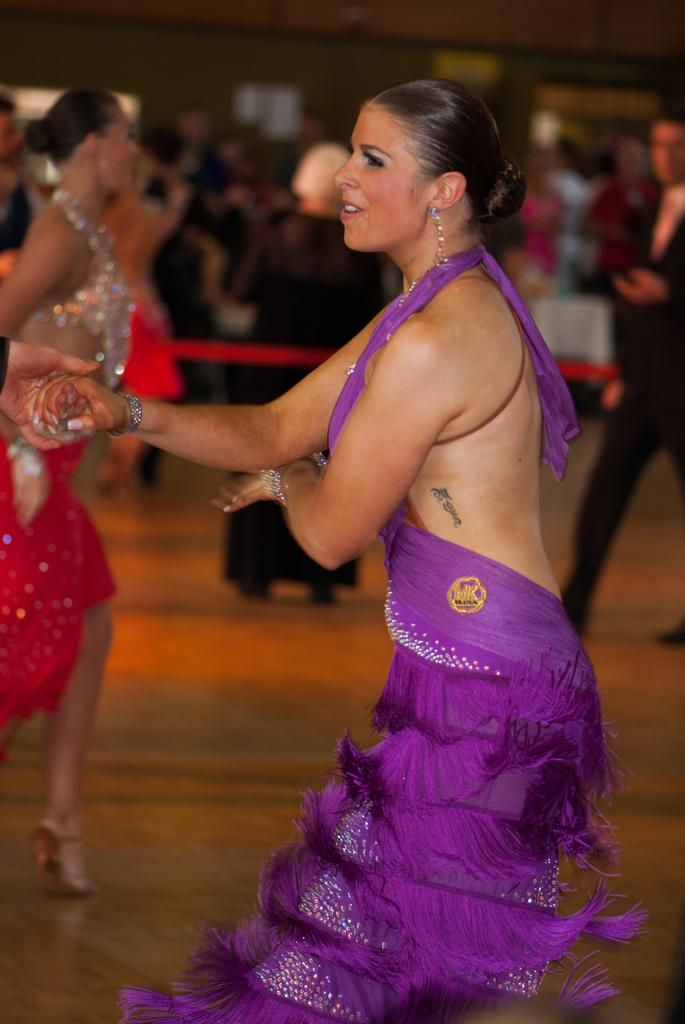What is the woman doing in the image? The woman is holding the hand of another person. Can you describe the background of the image? The background of the image is blurry. Are there any other people visible in the image? Yes, there are people visible in the background. What type of brick is being used to build the sofa in the image? There is no sofa or brick present in the image. How does the tub affect the woman's interaction with the other person in the image? There is no tub present in the image, so it does not affect the woman's interaction with the other person. 